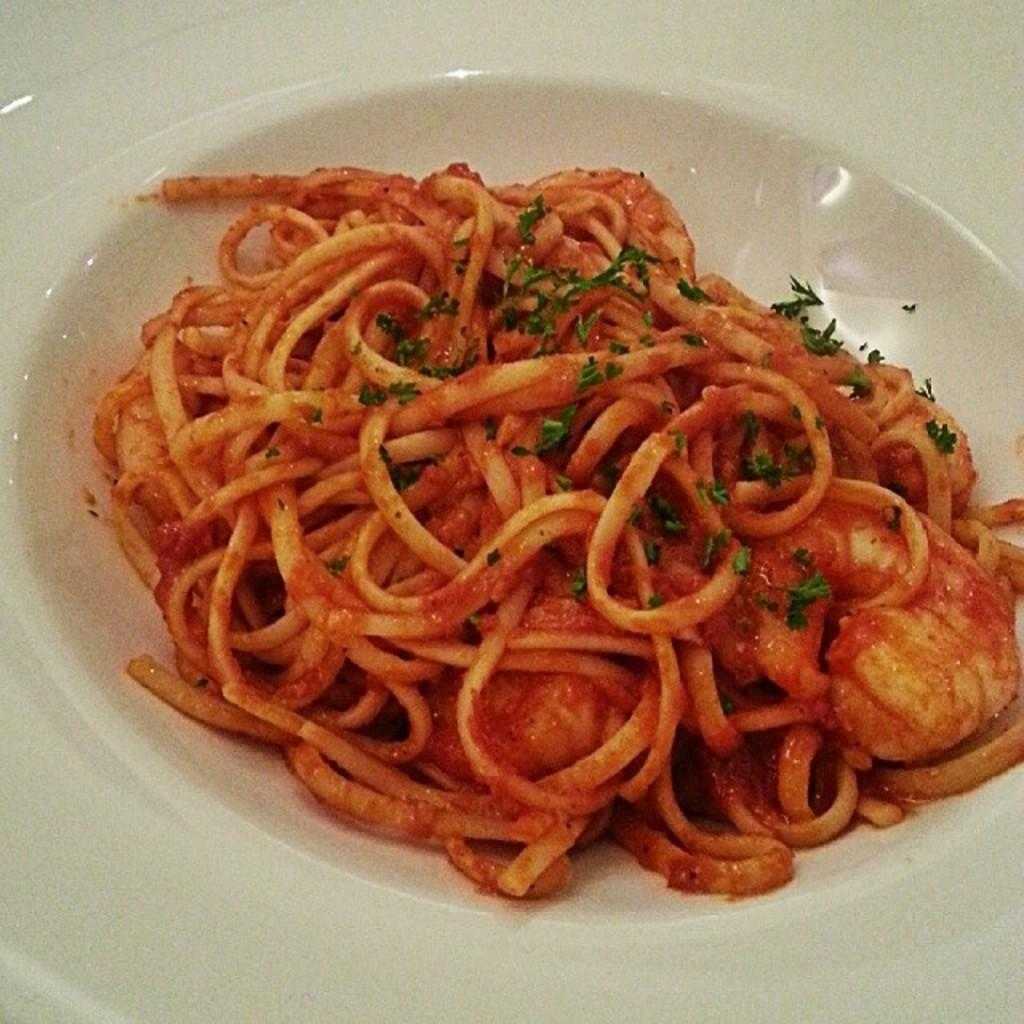What is present on the plate in the image? There is a food item in a plate in the image. Can you describe the food item on the plate? Unfortunately, the specific type of food item cannot be determined from the given facts. Is there any additional information about the food item or the plate? No, the only information provided is that there is a food item in a plate in the image. What type of mountain can be seen in the background of the image? There is no mountain present in the image; it only features a food item in a plate. What is the texture of the shoe depicted in the image? There is no shoe present in the image; it only features a food item in a plate. 